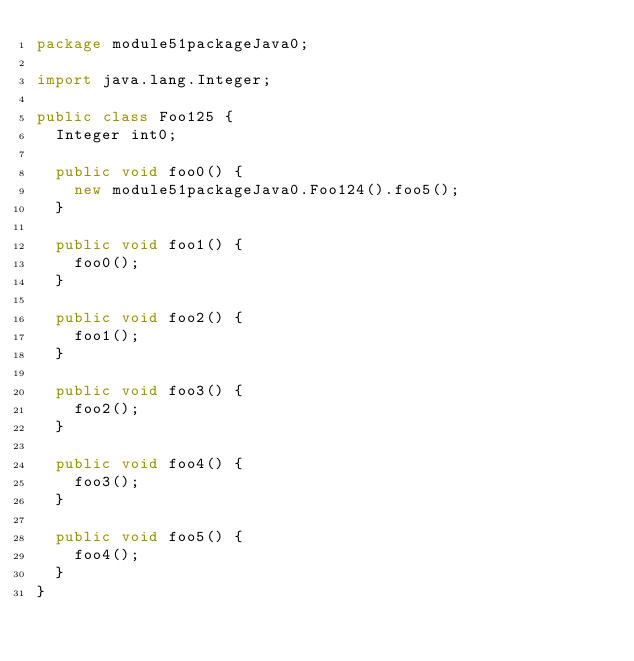Convert code to text. <code><loc_0><loc_0><loc_500><loc_500><_Java_>package module51packageJava0;

import java.lang.Integer;

public class Foo125 {
  Integer int0;

  public void foo0() {
    new module51packageJava0.Foo124().foo5();
  }

  public void foo1() {
    foo0();
  }

  public void foo2() {
    foo1();
  }

  public void foo3() {
    foo2();
  }

  public void foo4() {
    foo3();
  }

  public void foo5() {
    foo4();
  }
}
</code> 